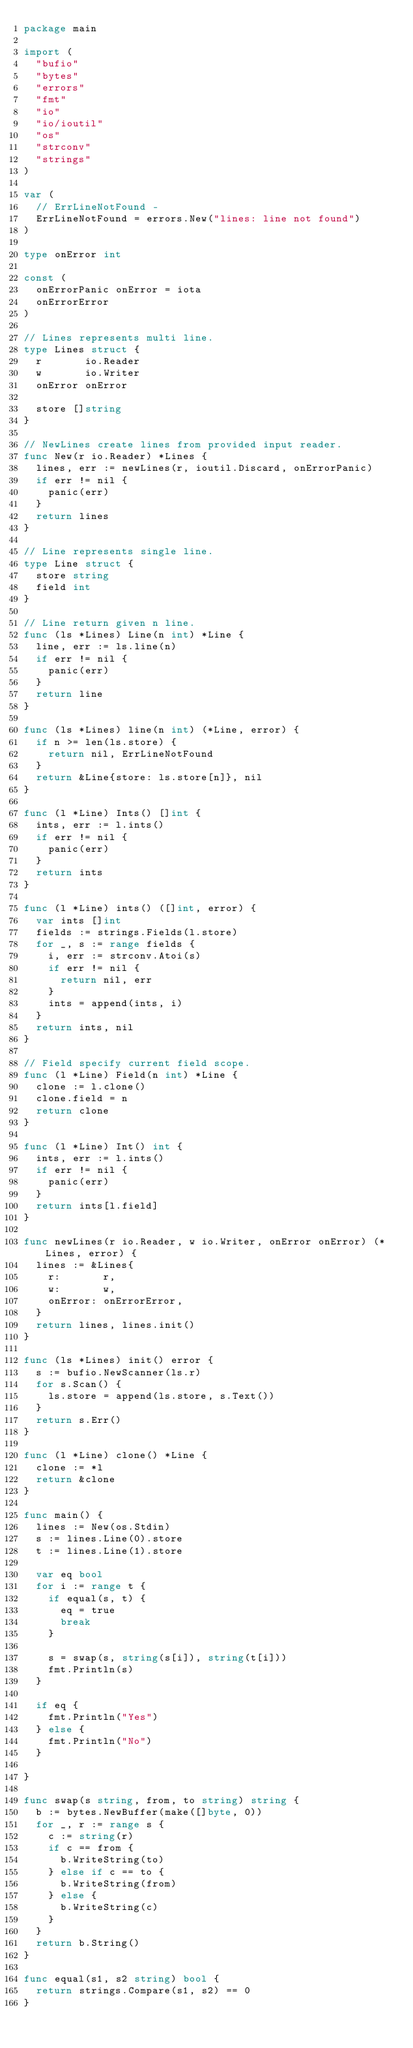Convert code to text. <code><loc_0><loc_0><loc_500><loc_500><_Go_>package main

import (
	"bufio"
	"bytes"
	"errors"
	"fmt"
	"io"
	"io/ioutil"
	"os"
	"strconv"
	"strings"
)

var (
	// ErrLineNotFound -
	ErrLineNotFound = errors.New("lines: line not found")
)

type onError int

const (
	onErrorPanic onError = iota
	onErrorError
)

// Lines represents multi line.
type Lines struct {
	r       io.Reader
	w       io.Writer
	onError onError

	store []string
}

// NewLines create lines from provided input reader.
func New(r io.Reader) *Lines {
	lines, err := newLines(r, ioutil.Discard, onErrorPanic)
	if err != nil {
		panic(err)
	}
	return lines
}

// Line represents single line.
type Line struct {
	store string
	field int
}

// Line return given n line.
func (ls *Lines) Line(n int) *Line {
	line, err := ls.line(n)
	if err != nil {
		panic(err)
	}
	return line
}

func (ls *Lines) line(n int) (*Line, error) {
	if n >= len(ls.store) {
		return nil, ErrLineNotFound
	}
	return &Line{store: ls.store[n]}, nil
}

func (l *Line) Ints() []int {
	ints, err := l.ints()
	if err != nil {
		panic(err)
	}
	return ints
}

func (l *Line) ints() ([]int, error) {
	var ints []int
	fields := strings.Fields(l.store)
	for _, s := range fields {
		i, err := strconv.Atoi(s)
		if err != nil {
			return nil, err
		}
		ints = append(ints, i)
	}
	return ints, nil
}

// Field specify current field scope.
func (l *Line) Field(n int) *Line {
	clone := l.clone()
	clone.field = n
	return clone
}

func (l *Line) Int() int {
	ints, err := l.ints()
	if err != nil {
		panic(err)
	}
	return ints[l.field]
}

func newLines(r io.Reader, w io.Writer, onError onError) (*Lines, error) {
	lines := &Lines{
		r:       r,
		w:       w,
		onError: onErrorError,
	}
	return lines, lines.init()
}

func (ls *Lines) init() error {
	s := bufio.NewScanner(ls.r)
	for s.Scan() {
		ls.store = append(ls.store, s.Text())
	}
	return s.Err()
}

func (l *Line) clone() *Line {
	clone := *l
	return &clone
}

func main() {
	lines := New(os.Stdin)
	s := lines.Line(0).store
	t := lines.Line(1).store

	var eq bool
	for i := range t {
		if equal(s, t) {
			eq = true
			break
		}

		s = swap(s, string(s[i]), string(t[i]))
		fmt.Println(s)
	}

	if eq {
		fmt.Println("Yes")
	} else {
		fmt.Println("No")
	}

}

func swap(s string, from, to string) string {
	b := bytes.NewBuffer(make([]byte, 0))
	for _, r := range s {
		c := string(r)
		if c == from {
			b.WriteString(to)
		} else if c == to {
			b.WriteString(from)
		} else {
			b.WriteString(c)
		}
	}
	return b.String()
}

func equal(s1, s2 string) bool {
	return strings.Compare(s1, s2) == 0
}
</code> 